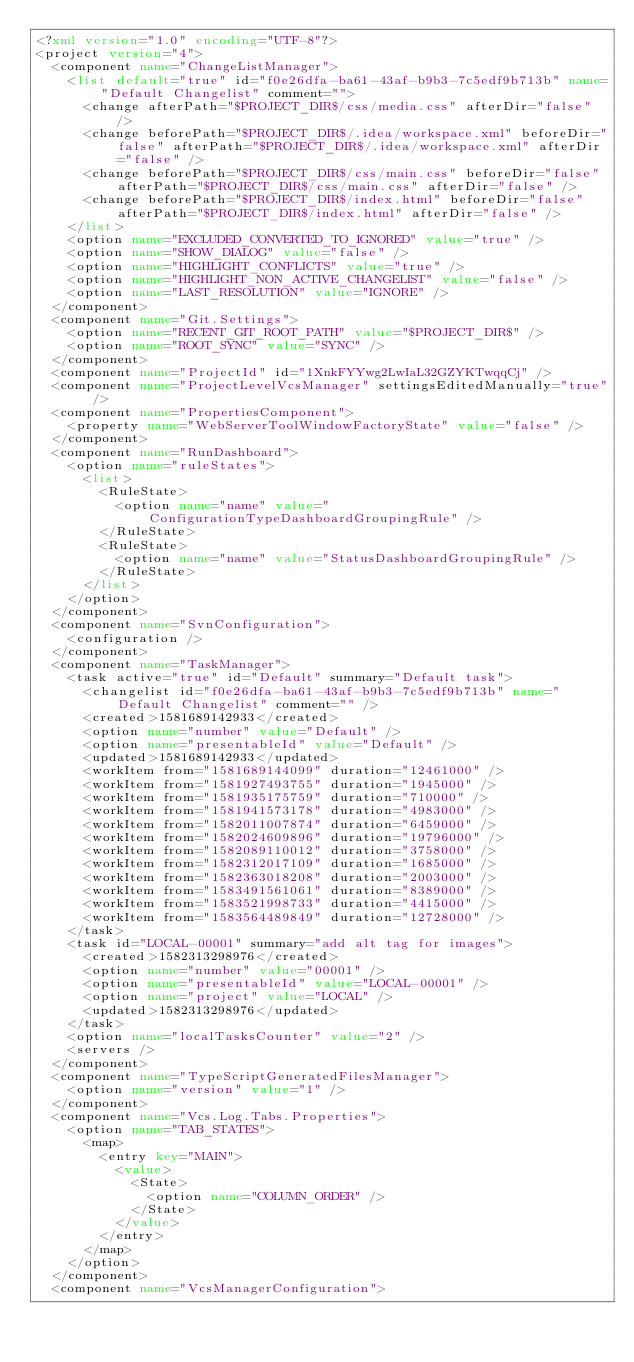Convert code to text. <code><loc_0><loc_0><loc_500><loc_500><_XML_><?xml version="1.0" encoding="UTF-8"?>
<project version="4">
  <component name="ChangeListManager">
    <list default="true" id="f0e26dfa-ba61-43af-b9b3-7c5edf9b713b" name="Default Changelist" comment="">
      <change afterPath="$PROJECT_DIR$/css/media.css" afterDir="false" />
      <change beforePath="$PROJECT_DIR$/.idea/workspace.xml" beforeDir="false" afterPath="$PROJECT_DIR$/.idea/workspace.xml" afterDir="false" />
      <change beforePath="$PROJECT_DIR$/css/main.css" beforeDir="false" afterPath="$PROJECT_DIR$/css/main.css" afterDir="false" />
      <change beforePath="$PROJECT_DIR$/index.html" beforeDir="false" afterPath="$PROJECT_DIR$/index.html" afterDir="false" />
    </list>
    <option name="EXCLUDED_CONVERTED_TO_IGNORED" value="true" />
    <option name="SHOW_DIALOG" value="false" />
    <option name="HIGHLIGHT_CONFLICTS" value="true" />
    <option name="HIGHLIGHT_NON_ACTIVE_CHANGELIST" value="false" />
    <option name="LAST_RESOLUTION" value="IGNORE" />
  </component>
  <component name="Git.Settings">
    <option name="RECENT_GIT_ROOT_PATH" value="$PROJECT_DIR$" />
    <option name="ROOT_SYNC" value="SYNC" />
  </component>
  <component name="ProjectId" id="1XnkFYYwg2LwIaL32GZYKTwqqCj" />
  <component name="ProjectLevelVcsManager" settingsEditedManually="true" />
  <component name="PropertiesComponent">
    <property name="WebServerToolWindowFactoryState" value="false" />
  </component>
  <component name="RunDashboard">
    <option name="ruleStates">
      <list>
        <RuleState>
          <option name="name" value="ConfigurationTypeDashboardGroupingRule" />
        </RuleState>
        <RuleState>
          <option name="name" value="StatusDashboardGroupingRule" />
        </RuleState>
      </list>
    </option>
  </component>
  <component name="SvnConfiguration">
    <configuration />
  </component>
  <component name="TaskManager">
    <task active="true" id="Default" summary="Default task">
      <changelist id="f0e26dfa-ba61-43af-b9b3-7c5edf9b713b" name="Default Changelist" comment="" />
      <created>1581689142933</created>
      <option name="number" value="Default" />
      <option name="presentableId" value="Default" />
      <updated>1581689142933</updated>
      <workItem from="1581689144099" duration="12461000" />
      <workItem from="1581927493755" duration="1945000" />
      <workItem from="1581935175759" duration="710000" />
      <workItem from="1581941573178" duration="4983000" />
      <workItem from="1582011007874" duration="6459000" />
      <workItem from="1582024609896" duration="19796000" />
      <workItem from="1582089110012" duration="3758000" />
      <workItem from="1582312017109" duration="1685000" />
      <workItem from="1582363018208" duration="2003000" />
      <workItem from="1583491561061" duration="8389000" />
      <workItem from="1583521998733" duration="4415000" />
      <workItem from="1583564489849" duration="12728000" />
    </task>
    <task id="LOCAL-00001" summary="add alt tag for images">
      <created>1582313298976</created>
      <option name="number" value="00001" />
      <option name="presentableId" value="LOCAL-00001" />
      <option name="project" value="LOCAL" />
      <updated>1582313298976</updated>
    </task>
    <option name="localTasksCounter" value="2" />
    <servers />
  </component>
  <component name="TypeScriptGeneratedFilesManager">
    <option name="version" value="1" />
  </component>
  <component name="Vcs.Log.Tabs.Properties">
    <option name="TAB_STATES">
      <map>
        <entry key="MAIN">
          <value>
            <State>
              <option name="COLUMN_ORDER" />
            </State>
          </value>
        </entry>
      </map>
    </option>
  </component>
  <component name="VcsManagerConfiguration"></code> 